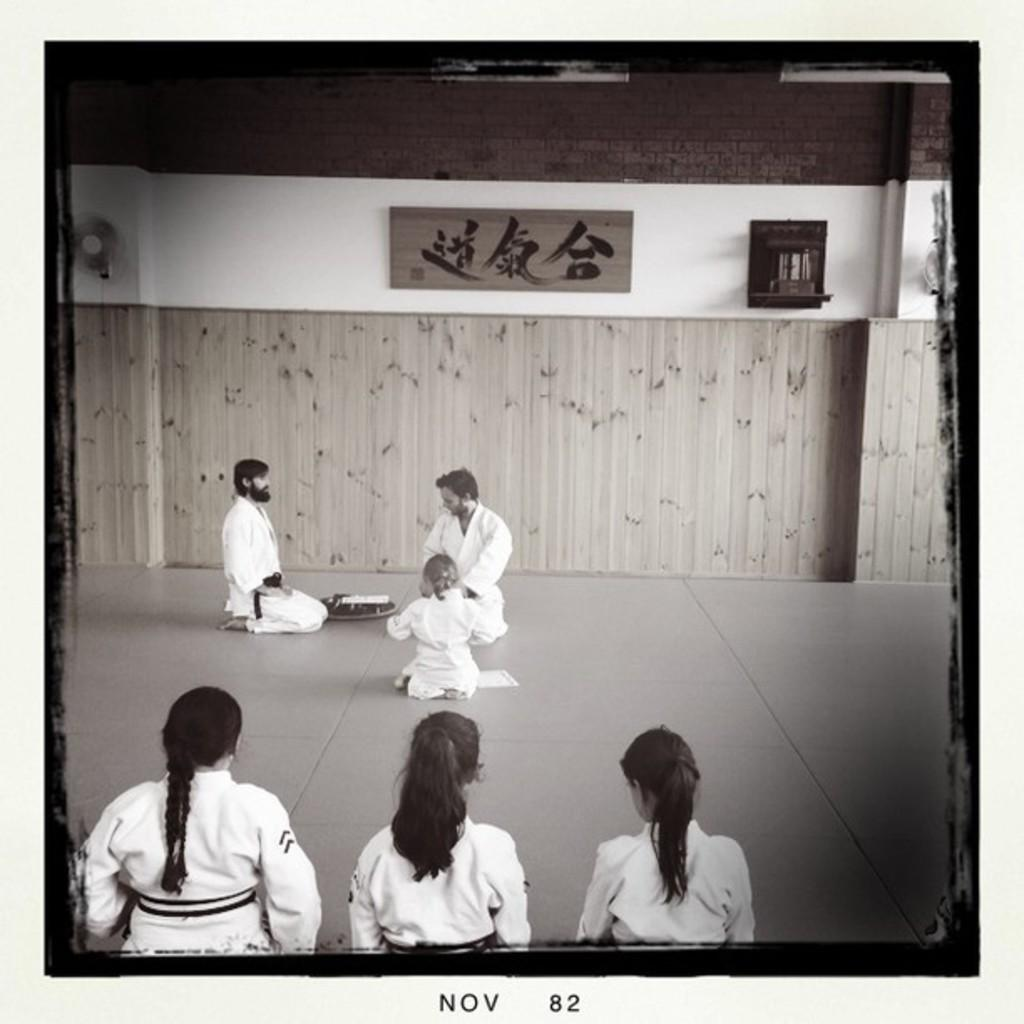What are the people in the image doing? The people in the image are sitting on the floor. What can be seen in the background of the image? There is a fan in the image. What object is present in the image that might be used for writing or displaying information? There is a board in the image, and something is written on it. What type of bean is visible in the image? There is no bean present in the image. How does the fan face the people in the image? The fan does not have a face, as it is an inanimate object. 